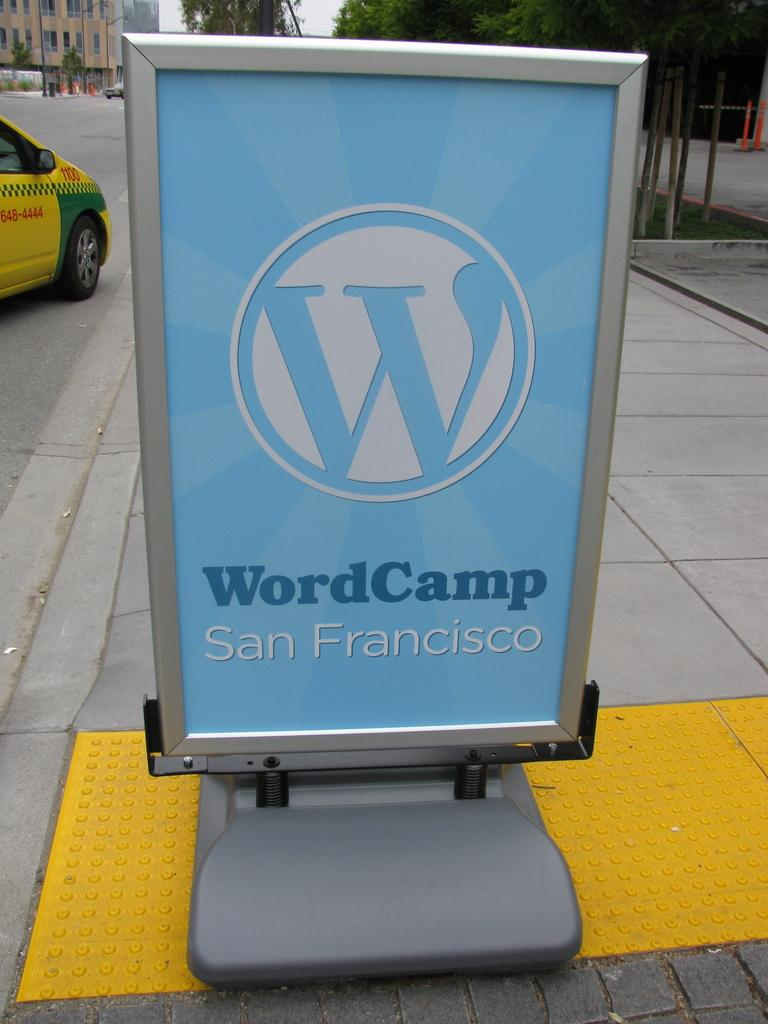<image>
Present a compact description of the photo's key features. A large sign for World Camp San Francisco sitting on concrete. 